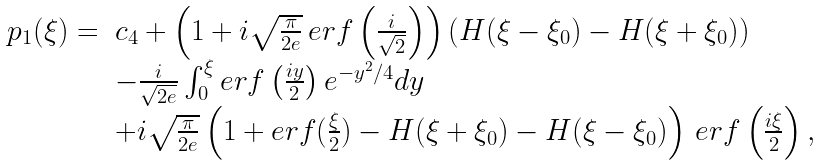<formula> <loc_0><loc_0><loc_500><loc_500>\begin{array} { r l } p _ { 1 } ( \xi ) = & c _ { 4 } + \left ( 1 + i \sqrt { \frac { \pi } { 2 e } } \, e r f \left ( \frac { i } { \sqrt { 2 } } \right ) \right ) ( H ( \xi - \xi _ { 0 } ) - H ( \xi + \xi _ { 0 } ) ) \\ & - \frac { i } { \sqrt { 2 e } } \int _ { 0 } ^ { \xi } e r f \left ( \frac { i y } { 2 } \right ) e ^ { - y ^ { 2 } / 4 } d y \\ & + i \sqrt { \frac { \pi } { 2 e } } \left ( 1 + e r f ( \frac { \xi } { 2 } ) - H ( \xi + \xi _ { 0 } ) - H ( \xi - \xi _ { 0 } ) \right ) \, e r f \left ( \frac { i \xi } { 2 } \right ) , \end{array}</formula> 